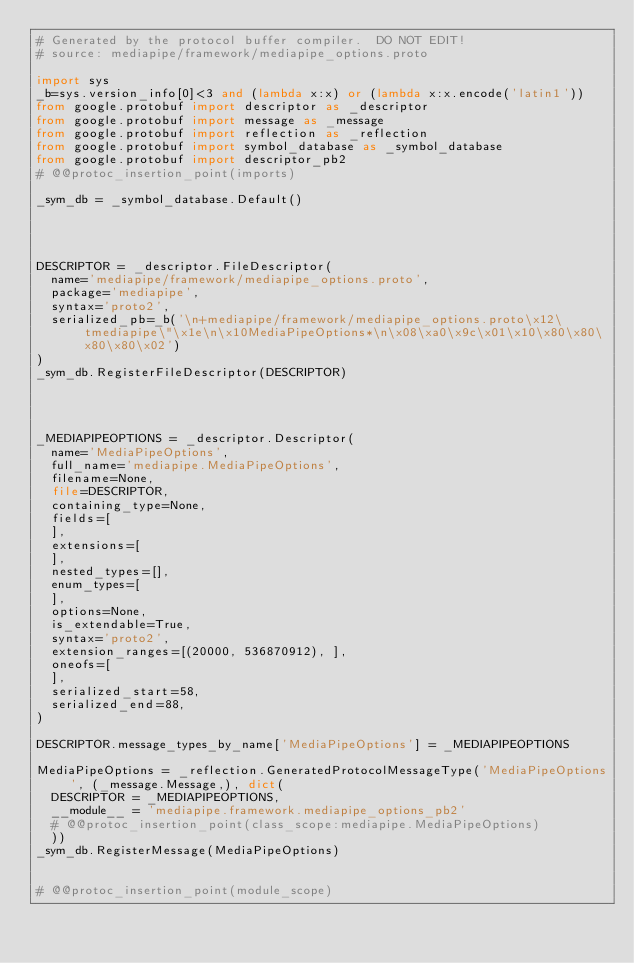Convert code to text. <code><loc_0><loc_0><loc_500><loc_500><_Python_># Generated by the protocol buffer compiler.  DO NOT EDIT!
# source: mediapipe/framework/mediapipe_options.proto

import sys
_b=sys.version_info[0]<3 and (lambda x:x) or (lambda x:x.encode('latin1'))
from google.protobuf import descriptor as _descriptor
from google.protobuf import message as _message
from google.protobuf import reflection as _reflection
from google.protobuf import symbol_database as _symbol_database
from google.protobuf import descriptor_pb2
# @@protoc_insertion_point(imports)

_sym_db = _symbol_database.Default()




DESCRIPTOR = _descriptor.FileDescriptor(
  name='mediapipe/framework/mediapipe_options.proto',
  package='mediapipe',
  syntax='proto2',
  serialized_pb=_b('\n+mediapipe/framework/mediapipe_options.proto\x12\tmediapipe\"\x1e\n\x10MediaPipeOptions*\n\x08\xa0\x9c\x01\x10\x80\x80\x80\x80\x02')
)
_sym_db.RegisterFileDescriptor(DESCRIPTOR)




_MEDIAPIPEOPTIONS = _descriptor.Descriptor(
  name='MediaPipeOptions',
  full_name='mediapipe.MediaPipeOptions',
  filename=None,
  file=DESCRIPTOR,
  containing_type=None,
  fields=[
  ],
  extensions=[
  ],
  nested_types=[],
  enum_types=[
  ],
  options=None,
  is_extendable=True,
  syntax='proto2',
  extension_ranges=[(20000, 536870912), ],
  oneofs=[
  ],
  serialized_start=58,
  serialized_end=88,
)

DESCRIPTOR.message_types_by_name['MediaPipeOptions'] = _MEDIAPIPEOPTIONS

MediaPipeOptions = _reflection.GeneratedProtocolMessageType('MediaPipeOptions', (_message.Message,), dict(
  DESCRIPTOR = _MEDIAPIPEOPTIONS,
  __module__ = 'mediapipe.framework.mediapipe_options_pb2'
  # @@protoc_insertion_point(class_scope:mediapipe.MediaPipeOptions)
  ))
_sym_db.RegisterMessage(MediaPipeOptions)


# @@protoc_insertion_point(module_scope)
</code> 